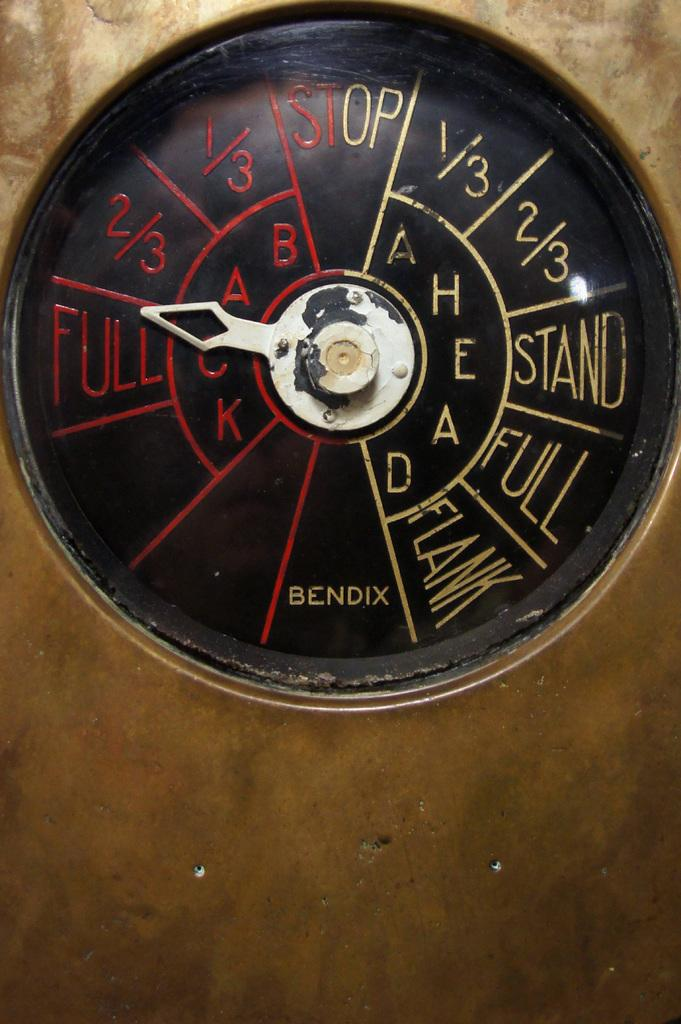<image>
Provide a brief description of the given image. Circular object that says BENDIX in yellow on the bottom. 